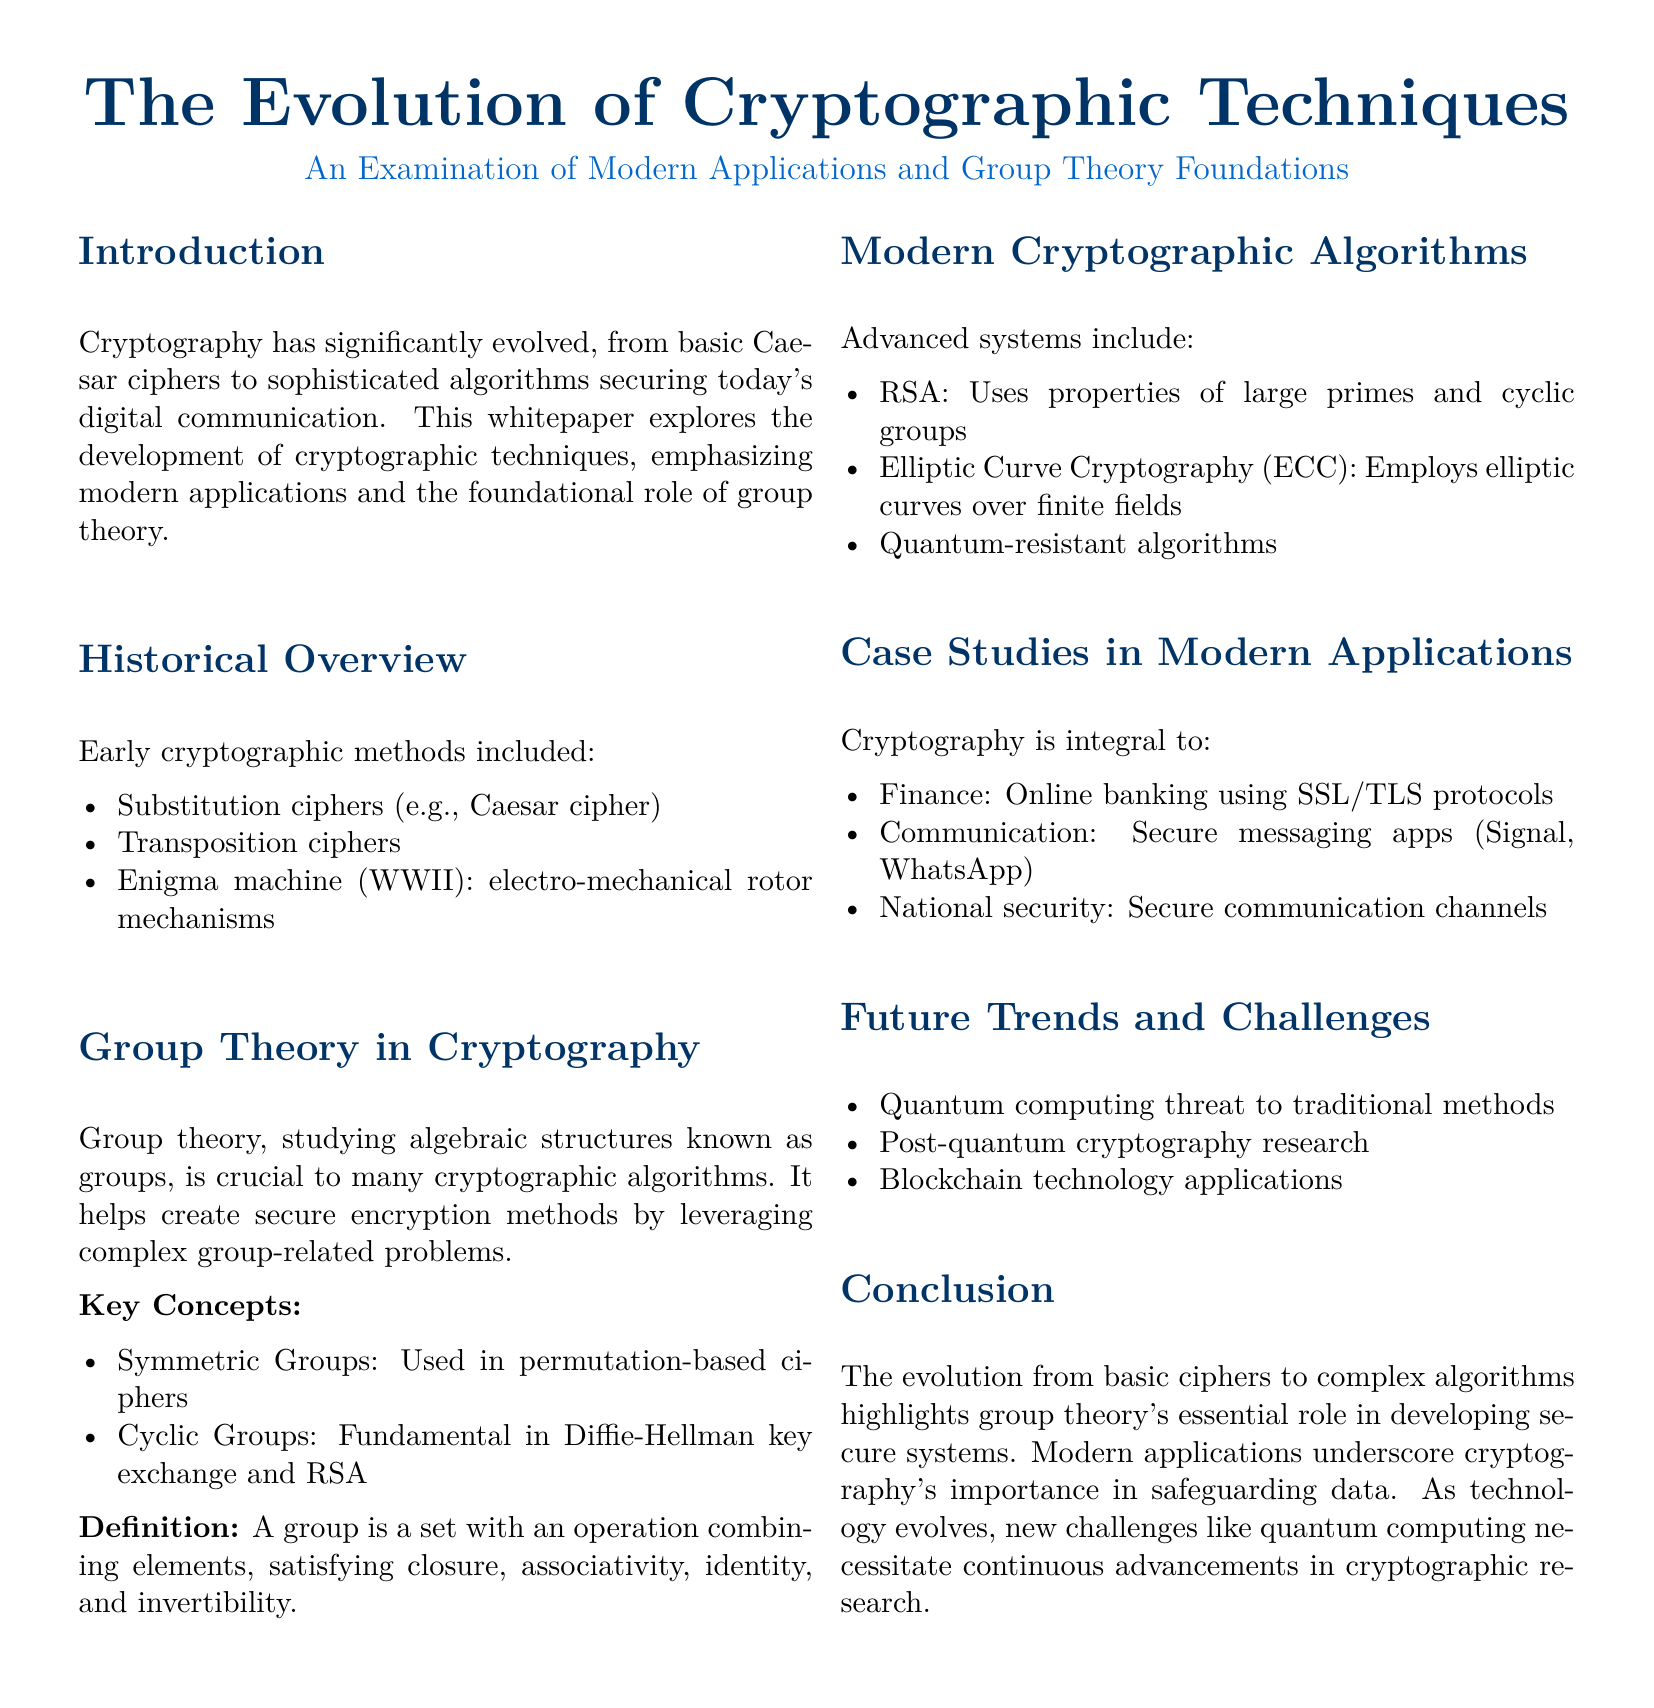What is the title of the whitepaper? The title is stated in the document and provides the main topic of discussion.
Answer: The Evolution of Cryptographic Techniques What mathematical structure is emphasized in cryptography? The document mentions group theory as a crucial foundational element in cryptography.
Answer: Group theory Name one early cryptographic method mentioned in the document. The historical overview section lists various early methods of cryptography, including this one.
Answer: Substitution ciphers Which modern algorithm uses properties of large primes? The document categorizes algorithms and specifies this one that utilizes the mentioned properties.
Answer: RSA What is one application of cryptography in finance according to the document? The case studies section discusses specific areas where cryptography is applied, particularly in finance.
Answer: Online banking using SSL/TLS protocols What is a challenge mentioned regarding future trends in cryptography? The whitepaper identifies potential threats or challenges that may impact cryptographic methods in the future.
Answer: Quantum computing threat What type of groups are fundamental in the Diffie-Hellman key exchange? The document describes the use of specific mathematical groups in various algorithms.
Answer: Cyclic Groups Identify one secure communication application mentioned in the document. The document provides examples of applications that rely on cryptographic techniques for secure communication.
Answer: Signal 